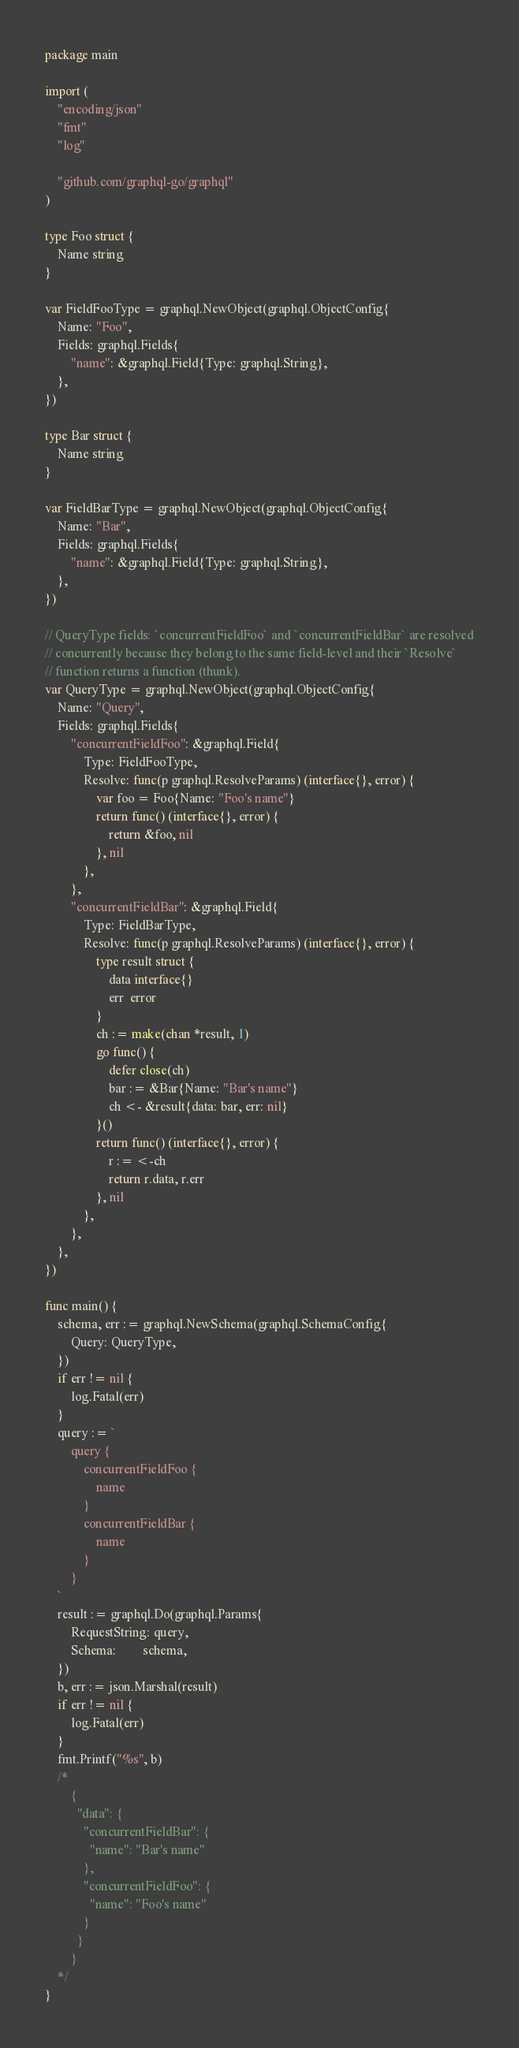<code> <loc_0><loc_0><loc_500><loc_500><_Go_>package main

import (
	"encoding/json"
	"fmt"
	"log"

	"github.com/graphql-go/graphql"
)

type Foo struct {
	Name string
}

var FieldFooType = graphql.NewObject(graphql.ObjectConfig{
	Name: "Foo",
	Fields: graphql.Fields{
		"name": &graphql.Field{Type: graphql.String},
	},
})

type Bar struct {
	Name string
}

var FieldBarType = graphql.NewObject(graphql.ObjectConfig{
	Name: "Bar",
	Fields: graphql.Fields{
		"name": &graphql.Field{Type: graphql.String},
	},
})

// QueryType fields: `concurrentFieldFoo` and `concurrentFieldBar` are resolved
// concurrently because they belong to the same field-level and their `Resolve`
// function returns a function (thunk).
var QueryType = graphql.NewObject(graphql.ObjectConfig{
	Name: "Query",
	Fields: graphql.Fields{
		"concurrentFieldFoo": &graphql.Field{
			Type: FieldFooType,
			Resolve: func(p graphql.ResolveParams) (interface{}, error) {
				var foo = Foo{Name: "Foo's name"}
				return func() (interface{}, error) {
					return &foo, nil
				}, nil
			},
		},
		"concurrentFieldBar": &graphql.Field{
			Type: FieldBarType,
			Resolve: func(p graphql.ResolveParams) (interface{}, error) {
				type result struct {
					data interface{}
					err  error
				}
				ch := make(chan *result, 1)
				go func() {
					defer close(ch)
					bar := &Bar{Name: "Bar's name"}
					ch <- &result{data: bar, err: nil}
				}()
				return func() (interface{}, error) {
					r := <-ch
					return r.data, r.err
				}, nil
			},
		},
	},
})

func main() {
	schema, err := graphql.NewSchema(graphql.SchemaConfig{
		Query: QueryType,
	})
	if err != nil {
		log.Fatal(err)
	}
	query := `
		query {
			concurrentFieldFoo {
				name
			}
			concurrentFieldBar {
				name
			}
		}
	`
	result := graphql.Do(graphql.Params{
		RequestString: query,
		Schema:        schema,
	})
	b, err := json.Marshal(result)
	if err != nil {
		log.Fatal(err)
	}
	fmt.Printf("%s", b)
	/*
		{
		  "data": {
		    "concurrentFieldBar": {
		      "name": "Bar's name"
		    },
		    "concurrentFieldFoo": {
		      "name": "Foo's name"
		    }
		  }
		}
	*/
}
</code> 